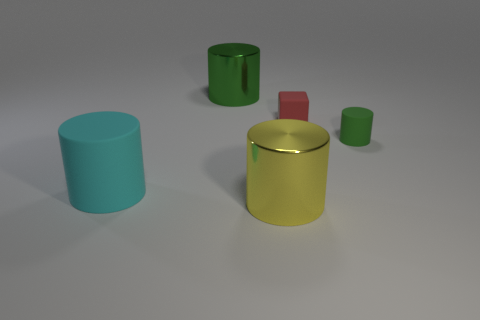Does the shiny cylinder behind the big yellow metal cylinder have the same color as the small matte cylinder?
Make the answer very short. Yes. Is the number of small cylinders greater than the number of blue matte blocks?
Provide a succinct answer. Yes. There is a large object that is to the left of the large yellow thing and in front of the tiny green thing; what is its shape?
Your response must be concise. Cylinder. Are there any small green metal things?
Provide a short and direct response. No. There is another large yellow thing that is the same shape as the large rubber thing; what material is it?
Your response must be concise. Metal. What shape is the metal thing that is in front of the large cylinder that is behind the green cylinder on the right side of the tiny red matte cube?
Provide a succinct answer. Cylinder. There is a big cylinder that is the same color as the small rubber cylinder; what is its material?
Offer a very short reply. Metal. What number of other rubber objects have the same shape as the large cyan thing?
Your answer should be compact. 1. There is a tiny rubber thing that is on the left side of the small green matte thing; does it have the same color as the metallic cylinder in front of the small green rubber cylinder?
Make the answer very short. No. There is a green object that is the same size as the cyan thing; what is its material?
Provide a succinct answer. Metal. 